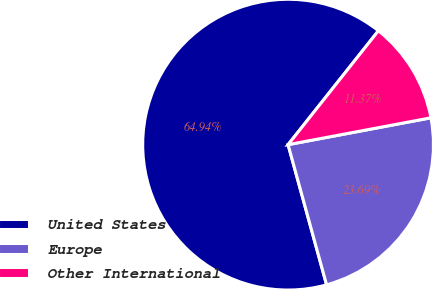<chart> <loc_0><loc_0><loc_500><loc_500><pie_chart><fcel>United States<fcel>Europe<fcel>Other International<nl><fcel>64.94%<fcel>23.69%<fcel>11.37%<nl></chart> 